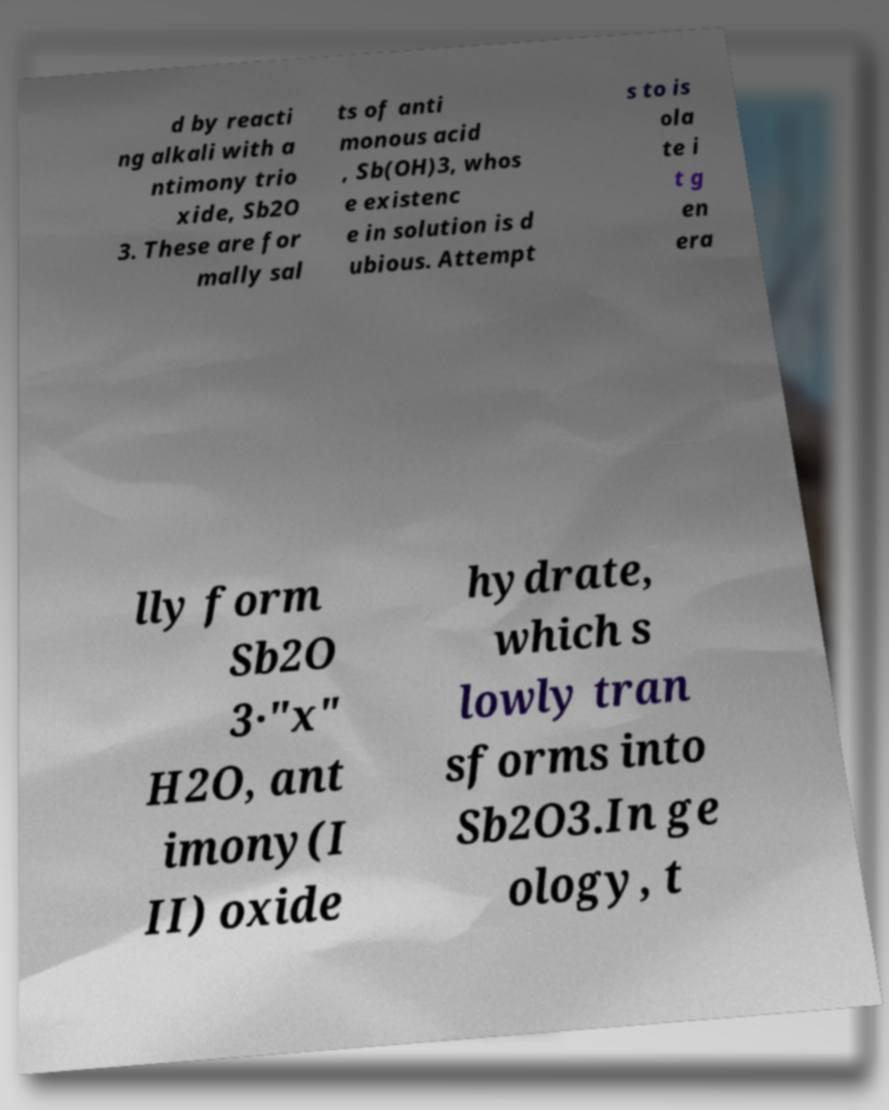Could you extract and type out the text from this image? d by reacti ng alkali with a ntimony trio xide, Sb2O 3. These are for mally sal ts of anti monous acid , Sb(OH)3, whos e existenc e in solution is d ubious. Attempt s to is ola te i t g en era lly form Sb2O 3·"x" H2O, ant imony(I II) oxide hydrate, which s lowly tran sforms into Sb2O3.In ge ology, t 